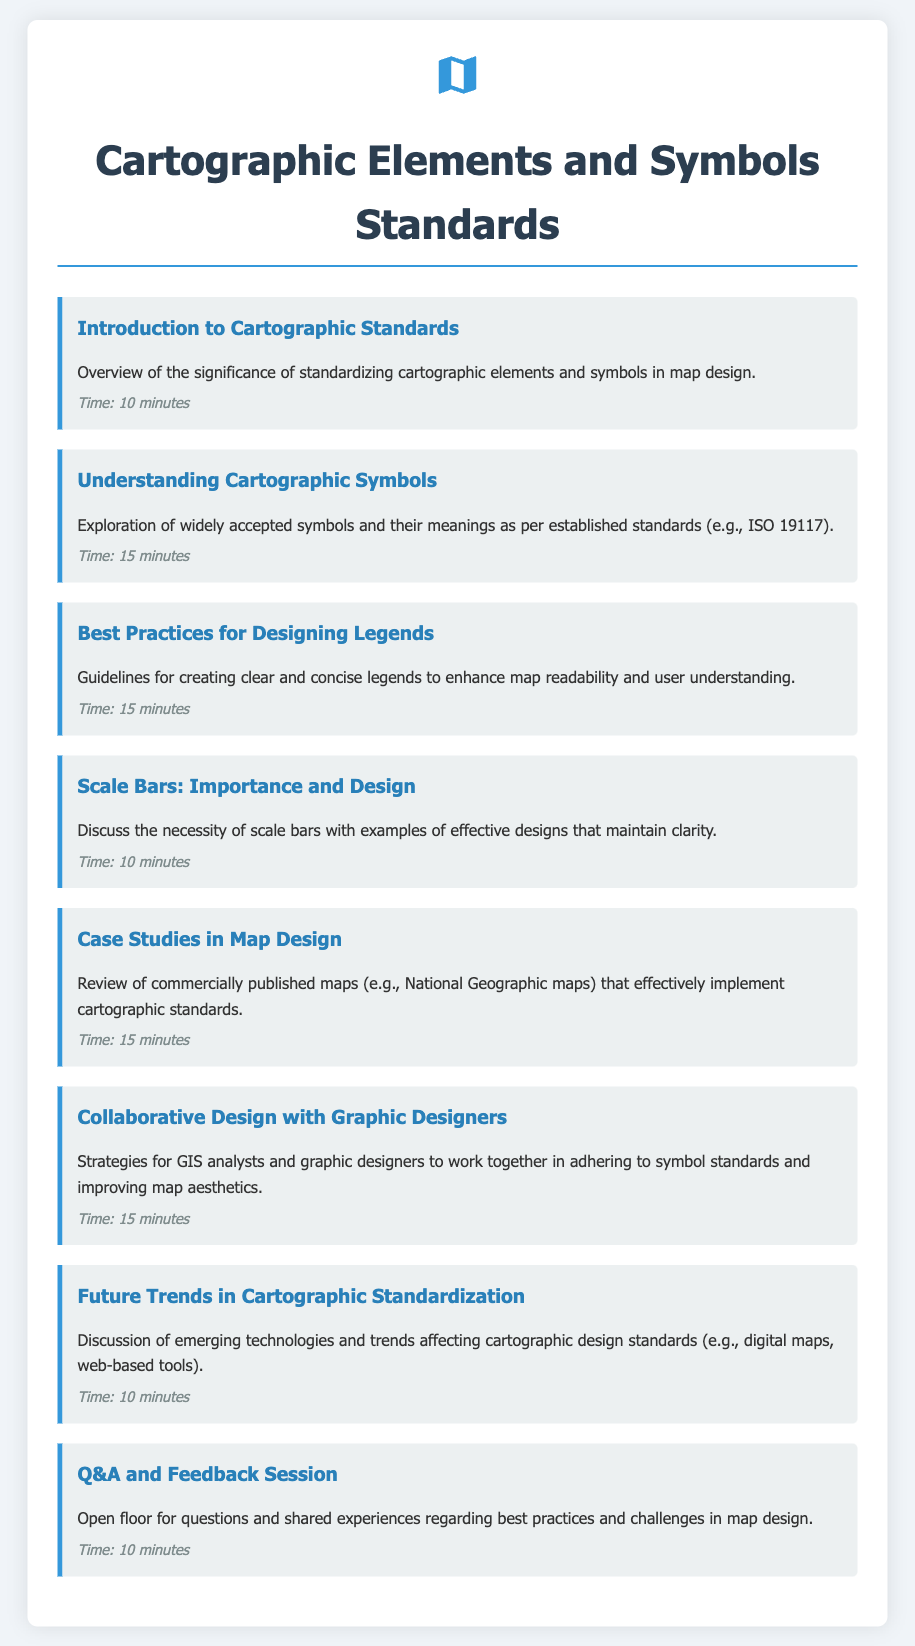what is the title of the document? The title is prominently displayed at the top of the document and indicates the main focus.
Answer: Cartographic Elements and Symbols Standards how long is the introduction to cartographic standards section? The time duration for this section is listed next to the title.
Answer: 10 minutes what is the main focus of the "Understanding Cartographic Symbols" agenda item? The description provides details about the content covered in this section.
Answer: Exploration of widely accepted symbols and their meanings how many minutes are allocated for the Q&A and Feedback Session? The duration is specified in the agenda item for that section.
Answer: 10 minutes which design aspect is discussed in the "Scale Bars: Importance and Design" section? The content focuses on the necessity of scale bars and design examples.
Answer: Importance and Design how many agenda items review case studies in map design? The agenda mentions only one item that covers this topic.
Answer: 1 what is the time allocation for the "Collaborative Design with Graphic Designers" item? The duration is mentioned in the description of the agenda item.
Answer: 15 minutes which technology trends are discussed in relation to cartographic design? The content specifies the emerging technologies that influence design standards.
Answer: Digital maps, web-based tools what color is used for the borders of the agenda items in the document? This detail is characterized by the styling specified for the agenda items.
Answer: #3498db 